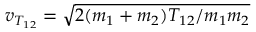Convert formula to latex. <formula><loc_0><loc_0><loc_500><loc_500>v _ { T _ { 1 2 } } = \sqrt { 2 ( m _ { 1 } + m _ { 2 } ) T _ { 1 2 } / m _ { 1 } m _ { 2 } }</formula> 